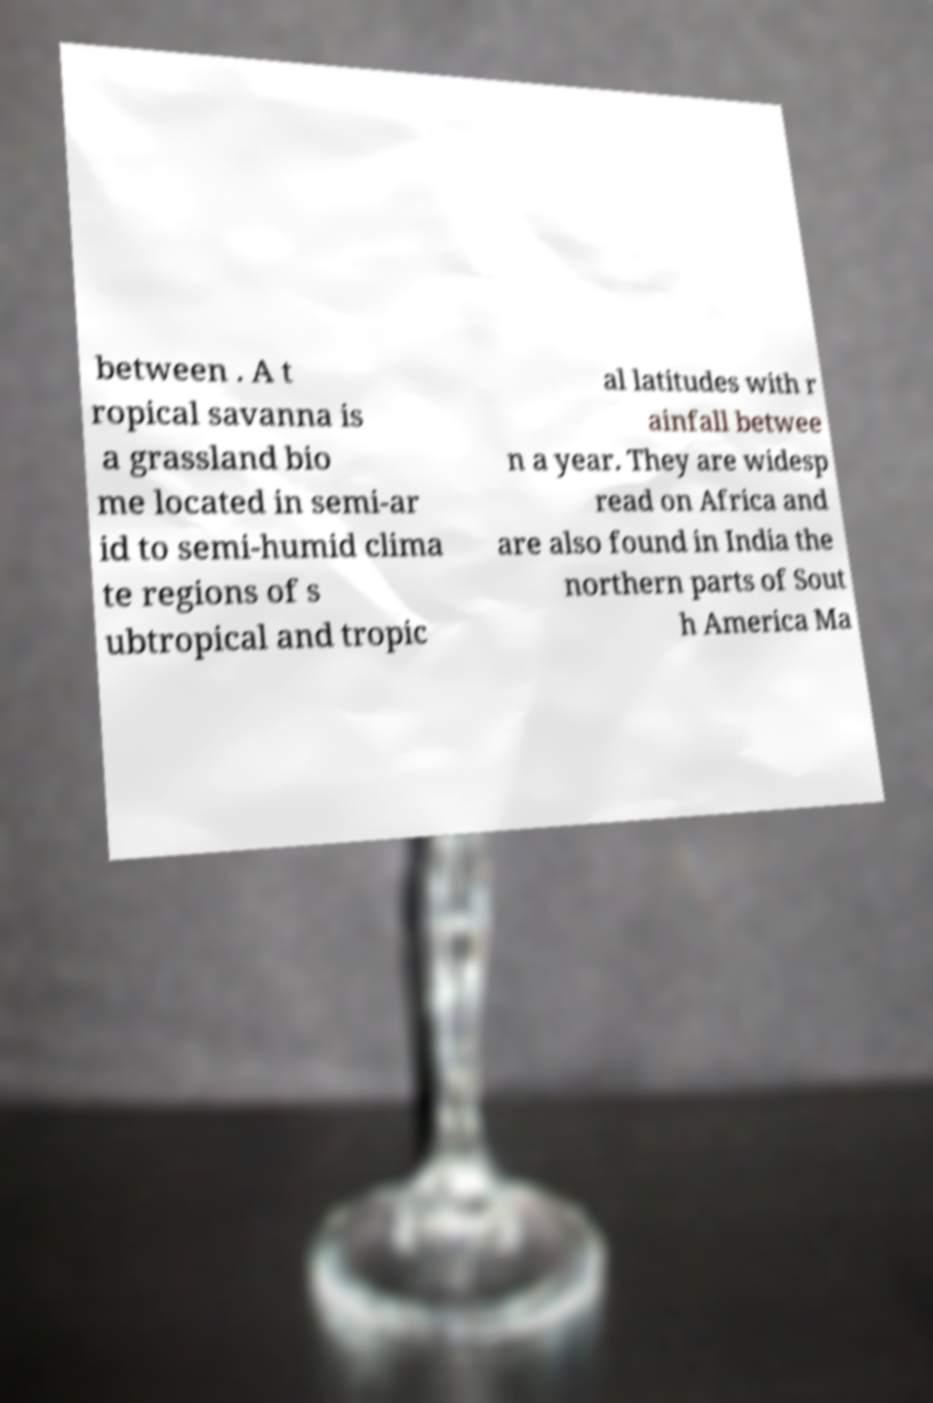Could you extract and type out the text from this image? between . A t ropical savanna is a grassland bio me located in semi-ar id to semi-humid clima te regions of s ubtropical and tropic al latitudes with r ainfall betwee n a year. They are widesp read on Africa and are also found in India the northern parts of Sout h America Ma 